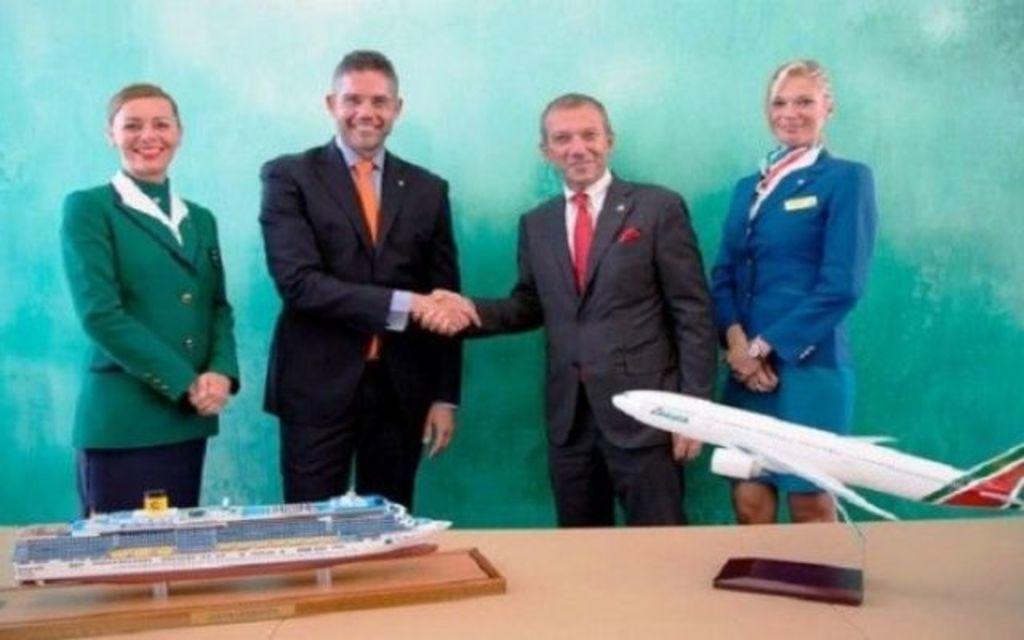In one or two sentences, can you explain what this image depicts? There are two men in the middle standing and shaking hands each other. To the left and right side we can see a woman standing and on a table there is a small ship on a platform and there is a plane on an object. 